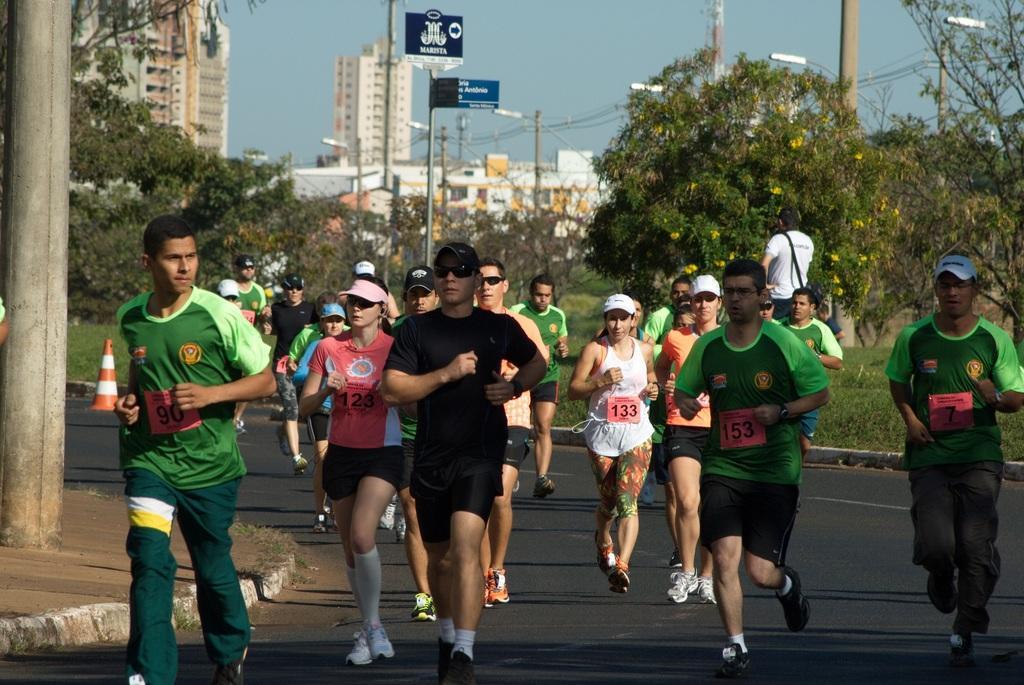How would you summarize this image in a sentence or two? Here in this picture we can see number of men and women walking and running on the road over there and we can see some people are wearing goggles and caps on them, we can see light posts, hoardings present here and there, behind them we can see plants and trees present all over there and we can also see buildings in the far over there. 